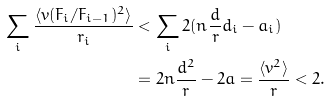<formula> <loc_0><loc_0><loc_500><loc_500>\sum _ { i } \frac { \langle v ( F _ { i } / F _ { i - 1 } ) ^ { 2 } \rangle } { r _ { i } } & < \sum _ { i } 2 ( n \frac { d } { r } d _ { i } - a _ { i } ) \\ & = 2 n \frac { d ^ { 2 } } { r } - 2 a = \frac { \langle v ^ { 2 } \rangle } { r } < 2 .</formula> 